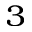Convert formula to latex. <formula><loc_0><loc_0><loc_500><loc_500>_ { 3 }</formula> 